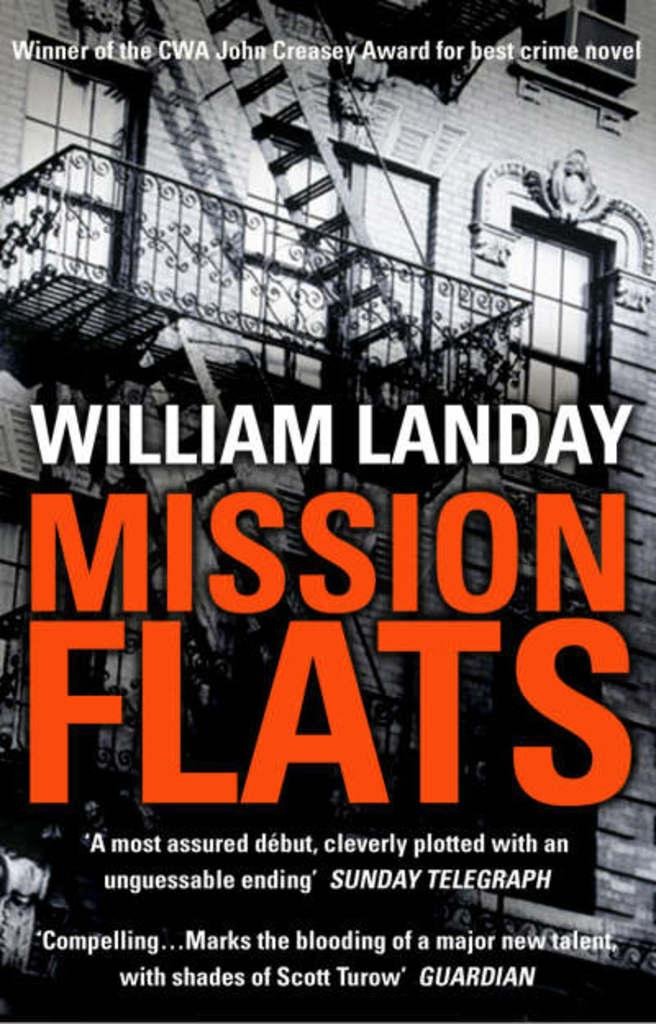<image>
Give a short and clear explanation of the subsequent image. A William Landay book called Mission Flats features an image of a fire escape. 